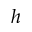<formula> <loc_0><loc_0><loc_500><loc_500>h</formula> 